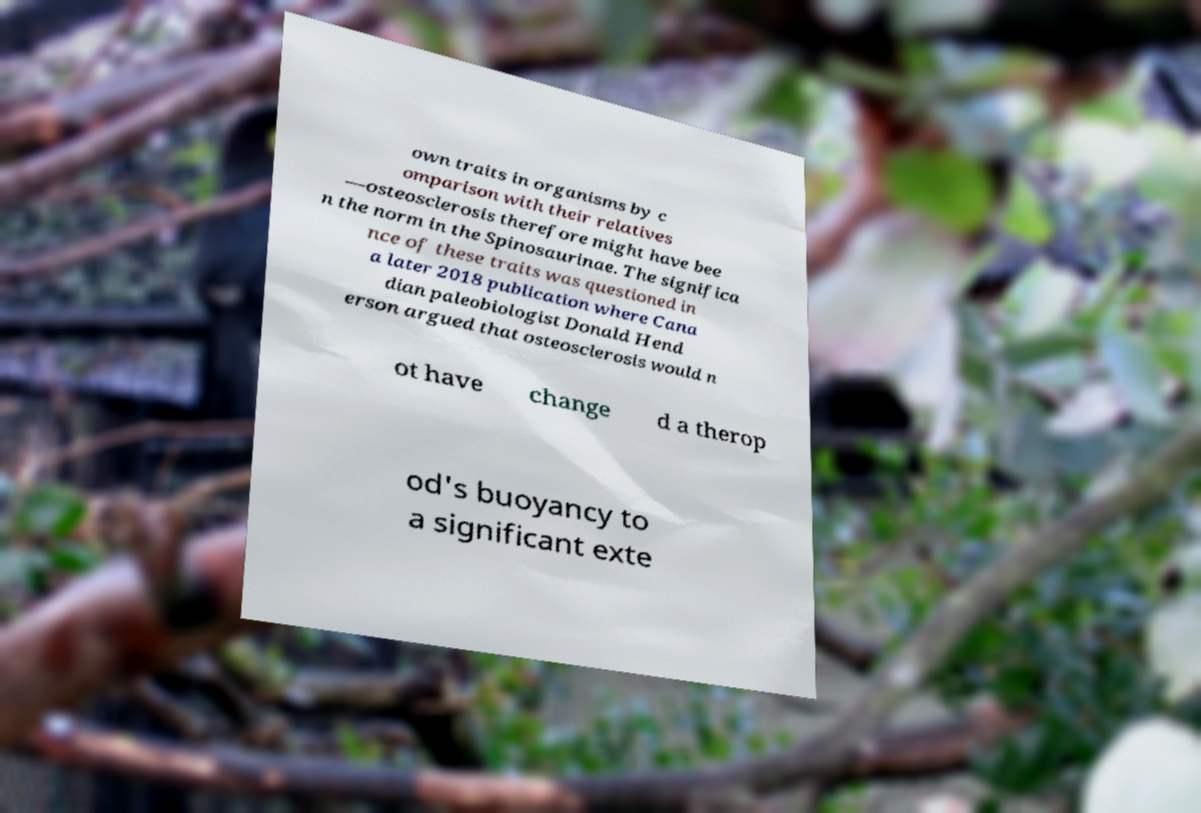I need the written content from this picture converted into text. Can you do that? own traits in organisms by c omparison with their relatives —osteosclerosis therefore might have bee n the norm in the Spinosaurinae. The significa nce of these traits was questioned in a later 2018 publication where Cana dian paleobiologist Donald Hend erson argued that osteosclerosis would n ot have change d a therop od's buoyancy to a significant exte 